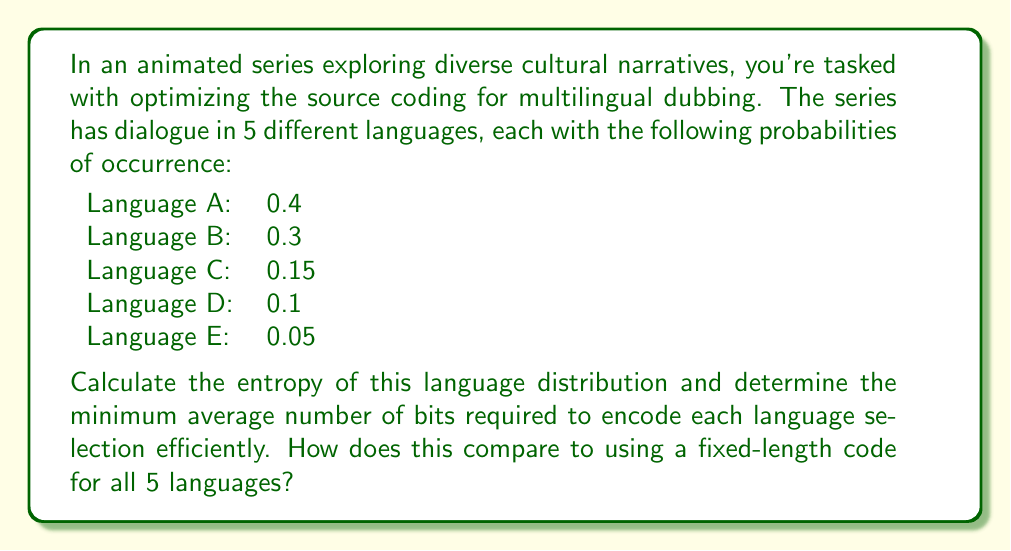Can you solve this math problem? To solve this problem, we'll use concepts from information theory, specifically entropy and source coding efficiency. Let's break it down step-by-step:

1. Calculate the entropy:
   The entropy H(X) is given by the formula:
   
   $$H(X) = -\sum_{i=1}^n p_i \log_2(p_i)$$

   Where $p_i$ is the probability of each outcome.

   Let's calculate each term:
   $$\begin{align*}
   -0.4 \log_2(0.4) &= 0.528771356\\
   -0.3 \log_2(0.3) &= 0.521245715\\
   -0.15 \log_2(0.15) &= 0.410239576\\
   -0.1 \log_2(0.1) &= 0.332192809\\
   -0.05 \log_2(0.05) &= 0.216096404
   \end{align*}$$

   Sum these values:
   $$H(X) = 0.528771356 + 0.521245715 + 0.410239576 + 0.332192809 + 0.216096404 = 2.00854586 \text{ bits}$$

2. Minimum average number of bits:
   The entropy represents the theoretical minimum average number of bits required to encode each language selection efficiently. Therefore, on average, we need 2.00854586 bits per language selection.

3. Comparison with fixed-length code:
   For a fixed-length code to represent 5 distinct languages, we would need $\lceil \log_2(5) \rceil = 3$ bits.

   The difference is:
   $$3 - 2.00854586 = 0.99145414 \text{ bits}$$

   This means that using an optimal variable-length code (such as a Huffman code) based on the given probabilities would save an average of about 0.99 bits per language selection compared to a fixed-length code.

   In percentage terms, this is a savings of:
   $$\frac{0.99145414}{3} \times 100\% \approx 33.05\%$$
Answer: The entropy of the language distribution is 2.00854586 bits. The minimum average number of bits required to encode each language selection efficiently is also 2.00854586 bits. Compared to a fixed-length code of 3 bits, an optimal variable-length code would save approximately 0.99 bits per selection, or about 33.05% in coding efficiency. 